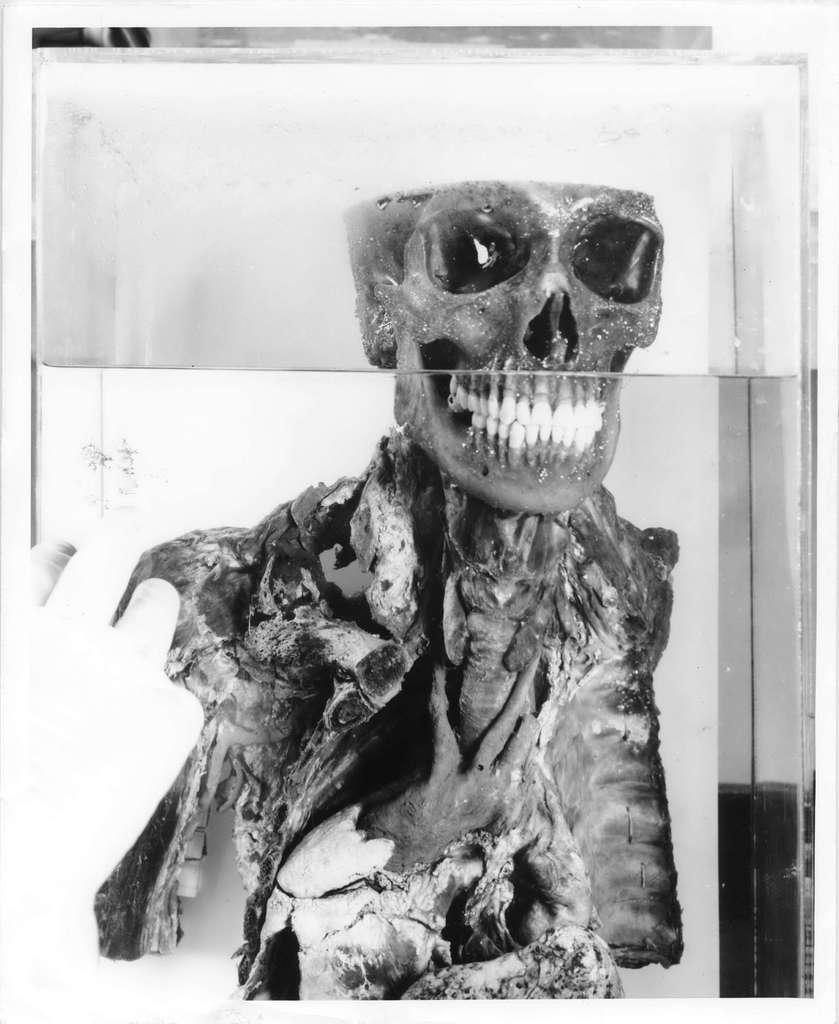What is the color scheme of the picture? The picture is black and white. What is the main subject of the image? There is a skeleton in the picture. How is the skeleton contained or displayed in the image? The skeleton is inside a glass box. What type of pump can be seen operating in the background of the image? There is no pump present in the image; it features a black and white picture of a skeleton inside a glass box. 